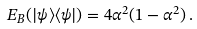Convert formula to latex. <formula><loc_0><loc_0><loc_500><loc_500>E _ { B } ( | \psi \rangle \langle \psi | ) = 4 \alpha ^ { 2 } ( 1 - \alpha ^ { 2 } ) \, .</formula> 